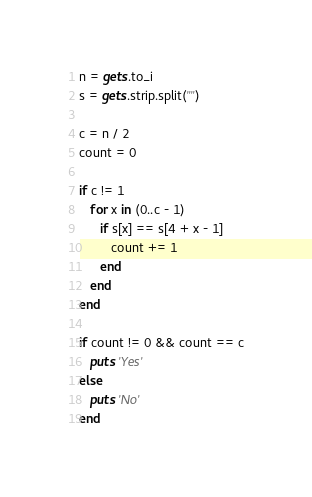<code> <loc_0><loc_0><loc_500><loc_500><_Ruby_>n = gets.to_i
s = gets.strip.split("")

c = n / 2
count = 0

if c != 1 
   for x in (0..c - 1)
      if s[x] == s[4 + x - 1]
         count += 1
      end
   end
end

if count != 0 && count == c
   puts 'Yes'   
else
   puts 'No'
end
</code> 